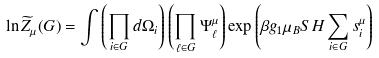Convert formula to latex. <formula><loc_0><loc_0><loc_500><loc_500>\ln \widetilde { Z } _ { \mu } ( G ) = \int \left ( \prod _ { i \in G } d \Omega _ { i } \right ) \left ( \prod _ { \ell \in G } \Psi _ { \ell } ^ { \mu } \right ) \exp \left ( \beta g _ { 1 } \mu _ { B } S H \sum _ { i \in G } s _ { i } ^ { \mu } \right )</formula> 